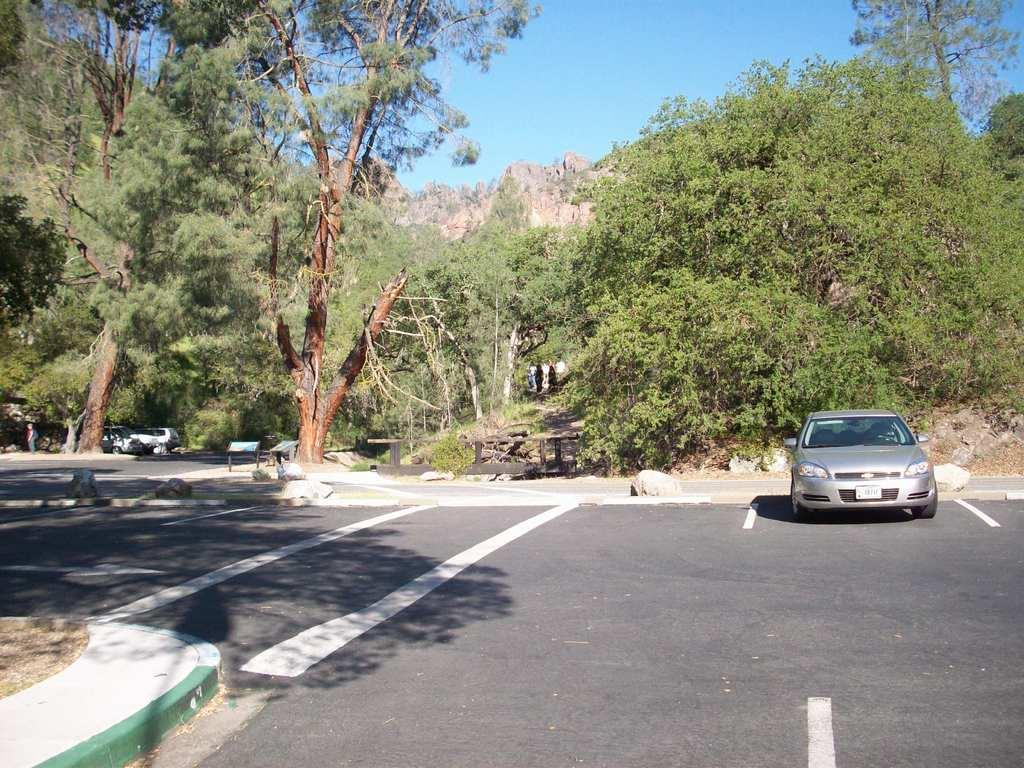What type of natural elements can be seen in the image? There are trees in the image. What geographical feature is present in the image? There is a hill in the image. What type of vehicles can be seen in the image? Cars are parked in the image. Can you describe the human presence in the image? It appears that there is a human standing on the sidewalk. What type of structure is present in the image? There is a wooden bridge in the image. What type of signage is present in the image? There are display boards in the image. What is the current hour according to the lawyer in the image? There is no lawyer present in the image, and therefore no indication of the current hour. What is the temper of the trees in the image? The trees in the image do not have a temper; they are inanimate objects. 